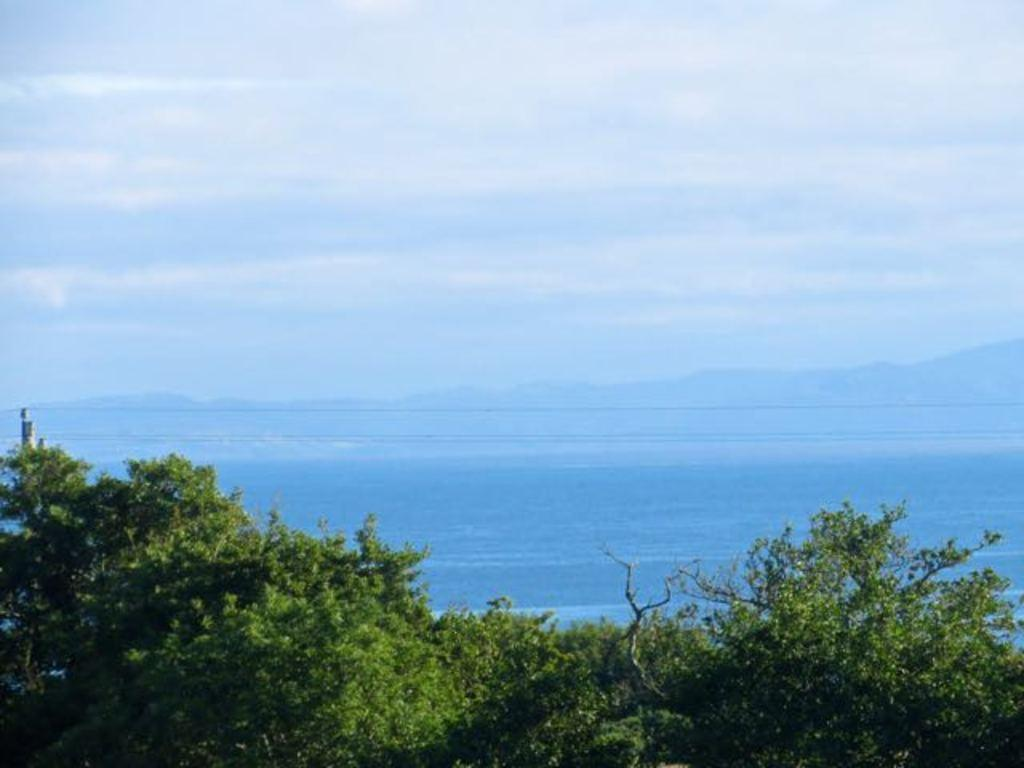What type of vegetation is at the bottom of the image? There are trees at the bottom of the image. What natural element is visible in the image besides the trees? There is water visible in the image. What type of landscape feature can be seen in the background of the image? There are mountains in the background of the image. What is visible at the top of the image? The sky is visible at the top of the image. Can you tell me how many horses are depicted in the image? There are no horses present in the image. What is the relationship between the trees and the sister in the image? There is no mention of a sister in the image, and the trees are not related to any person. 